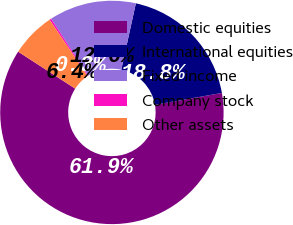Convert chart to OTSL. <chart><loc_0><loc_0><loc_500><loc_500><pie_chart><fcel>Domestic equities<fcel>International equities<fcel>Fixed income<fcel>Company stock<fcel>Other assets<nl><fcel>61.94%<fcel>18.77%<fcel>12.6%<fcel>0.26%<fcel>6.43%<nl></chart> 